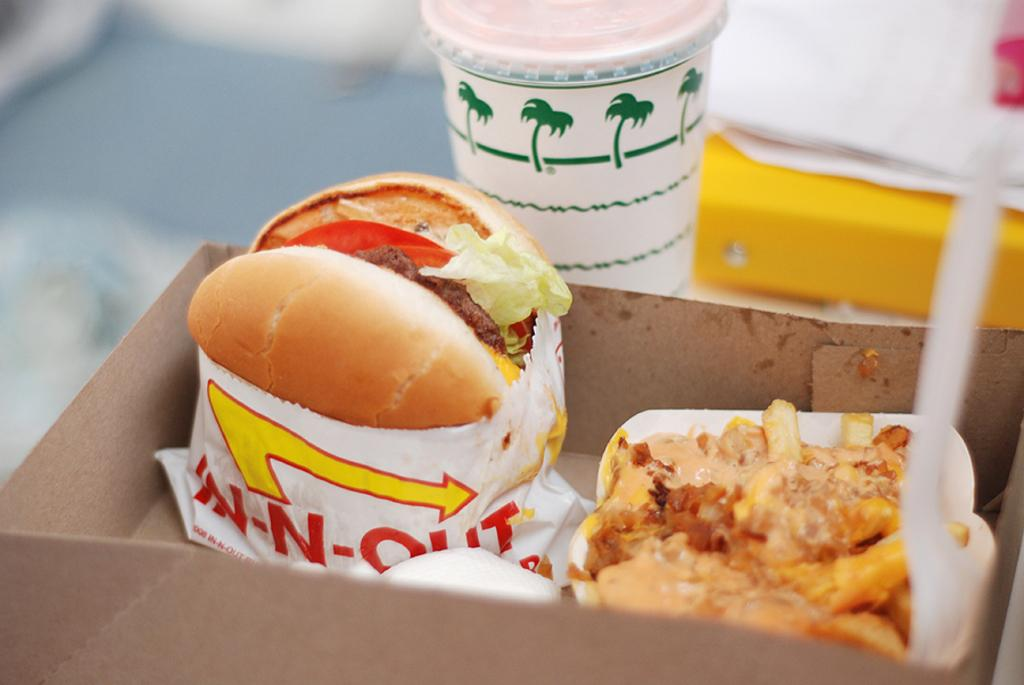What type of food is visible in the image? There is a burger and a sandwich in the image. Where are the burger and sandwich located? The burger and sandwich are in a box. What else can be seen in the image besides the food? There is a glass with a lid in the image. Where is the glass with a lid placed? The glass with a lid is placed on a table. What type of mine is depicted in the image? There is no mine present in the image; it features a burger, sandwich, box, and glass with a lid. What kind of competition is taking place in the image? There is no competition present in the image; it shows food items and a glass with a lid. 